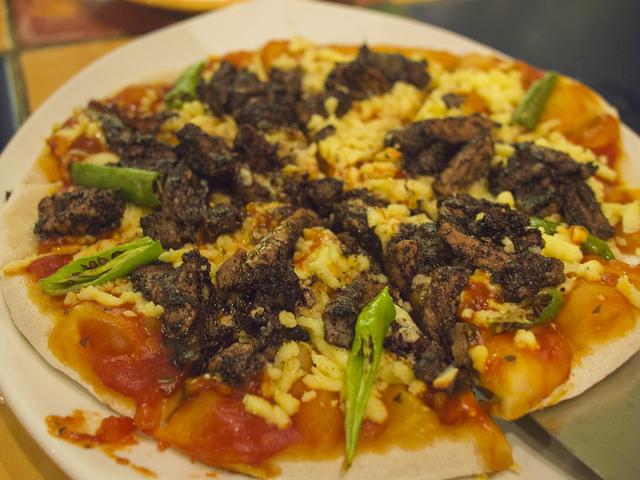What color is the plate?
Concise answer only. White. Who is going to eat this pizza?
Concise answer only. Person. Is this pizza nutritious enough to eat for a full dinner?
Write a very short answer. Yes. 